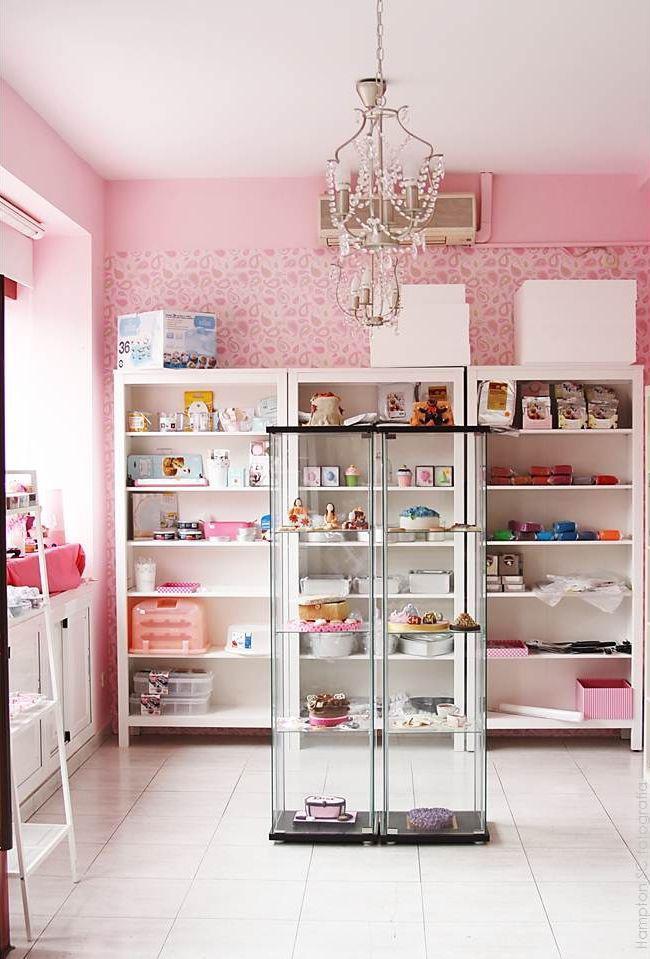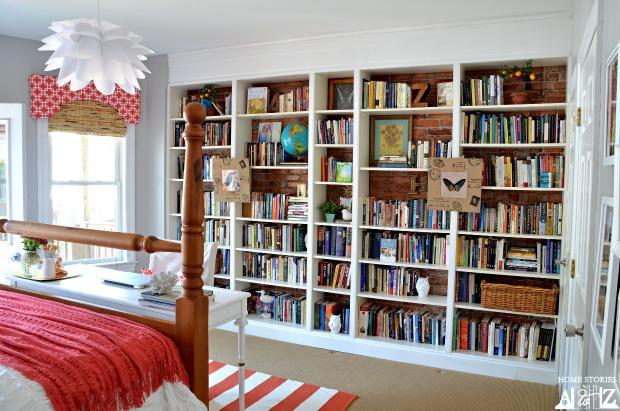The first image is the image on the left, the second image is the image on the right. Examine the images to the left and right. Is the description "At least one shelving unit is used as behind the fridge pantry space." accurate? Answer yes or no. No. The first image is the image on the left, the second image is the image on the right. For the images displayed, is the sentence "A narrow white pantry with filled shelves is extended out alongside a white refrigerator with no magnets on it, in the left image." factually correct? Answer yes or no. No. 